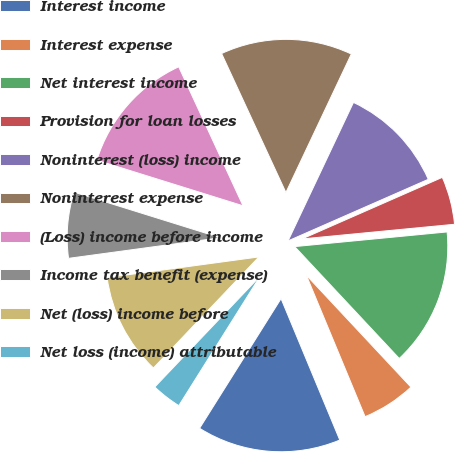<chart> <loc_0><loc_0><loc_500><loc_500><pie_chart><fcel>Interest income<fcel>Interest expense<fcel>Net interest income<fcel>Provision for loan losses<fcel>Noninterest (loss) income<fcel>Noninterest expense<fcel>(Loss) income before income<fcel>Income tax benefit (expense)<fcel>Net (loss) income before<fcel>Net loss (income) attributable<nl><fcel>15.19%<fcel>5.7%<fcel>14.56%<fcel>5.06%<fcel>11.39%<fcel>13.92%<fcel>13.29%<fcel>6.96%<fcel>10.76%<fcel>3.16%<nl></chart> 